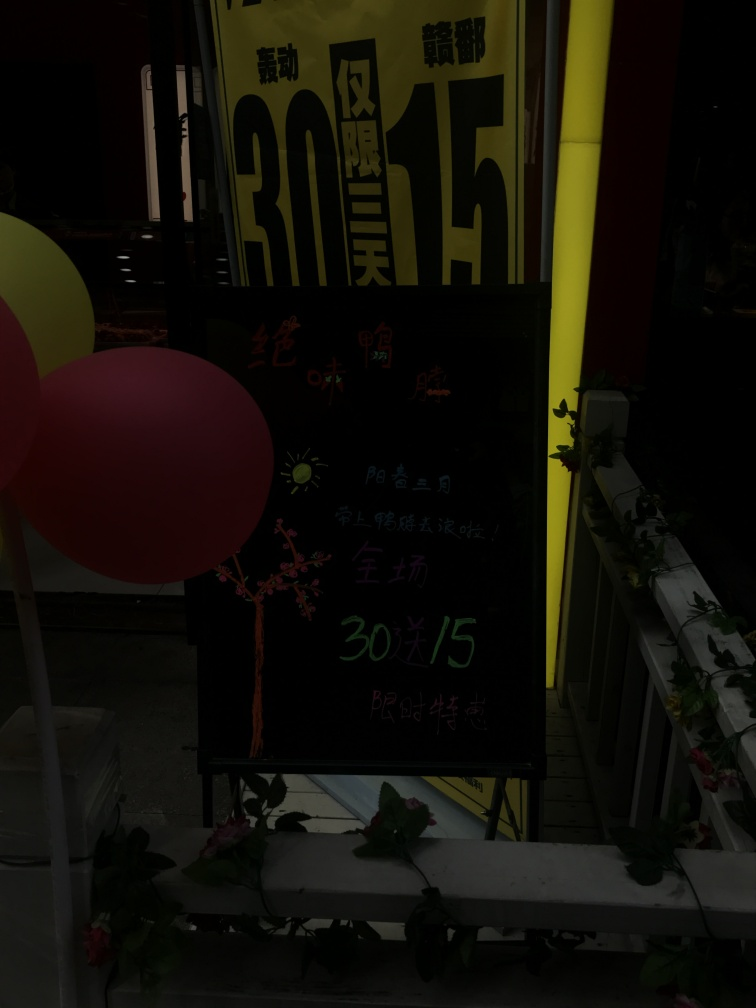Is the quality of this image poor? The quality of the image provided is not optimal. It appears underexposed, with significant portions of the scene shrouded in darkness which prevents clear visibility of details. The subject, which seems to be a sign with text, is partially discernible but lacks the sharpness and clarity that would be present in a higher quality photo. It's essential to ensure adequate lighting when capturing images to avoid such issues. 